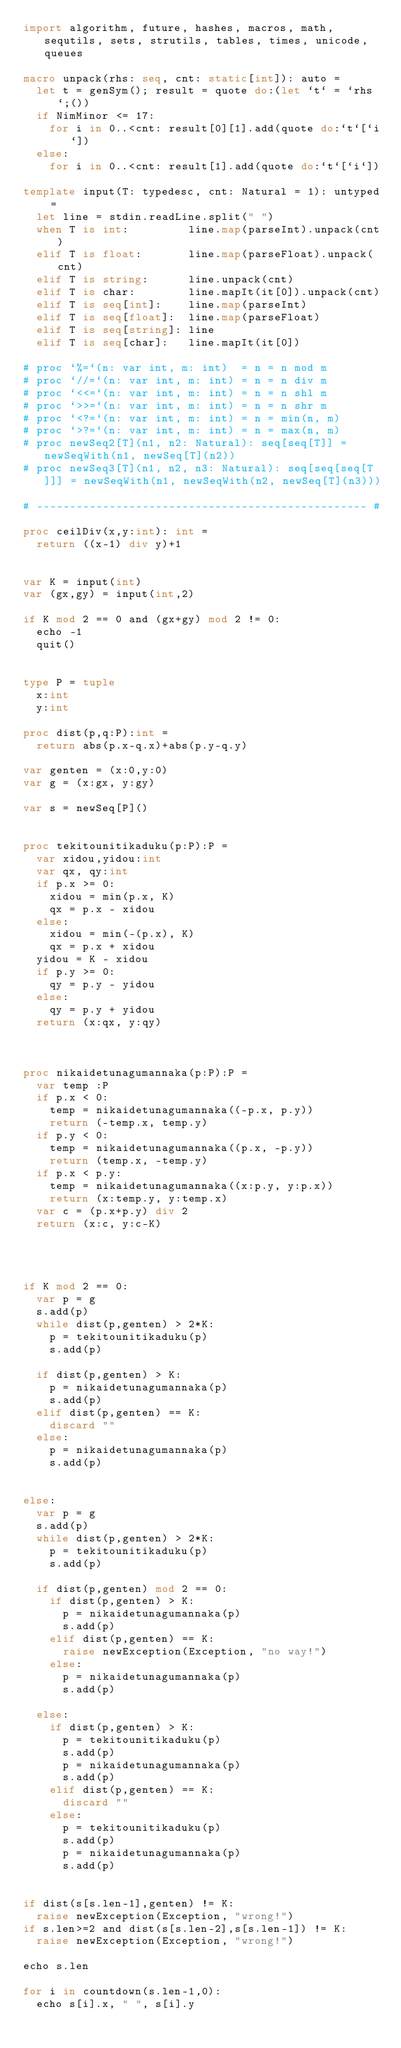Convert code to text. <code><loc_0><loc_0><loc_500><loc_500><_Nim_>import algorithm, future, hashes, macros, math, sequtils, sets, strutils, tables, times, unicode, queues
 
macro unpack(rhs: seq, cnt: static[int]): auto =
  let t = genSym(); result = quote do:(let `t` = `rhs`;())
  if NimMinor <= 17:
    for i in 0..<cnt: result[0][1].add(quote do:`t`[`i`])
  else:
    for i in 0..<cnt: result[1].add(quote do:`t`[`i`])
 
template input(T: typedesc, cnt: Natural = 1): untyped =
  let line = stdin.readLine.split(" ")
  when T is int:         line.map(parseInt).unpack(cnt)
  elif T is float:       line.map(parseFloat).unpack(cnt)
  elif T is string:      line.unpack(cnt)
  elif T is char:        line.mapIt(it[0]).unpack(cnt)
  elif T is seq[int]:    line.map(parseInt)
  elif T is seq[float]:  line.map(parseFloat)
  elif T is seq[string]: line
  elif T is seq[char]:   line.mapIt(it[0])
 
# proc `%=`(n: var int, m: int)  = n = n mod m
# proc `//=`(n: var int, m: int) = n = n div m
# proc `<<=`(n: var int, m: int) = n = n shl m
# proc `>>=`(n: var int, m: int) = n = n shr m
# proc `<?=`(n: var int, m: int) = n = min(n, m)
# proc `>?=`(n: var int, m: int) = n = max(n, m)
# proc newSeq2[T](n1, n2: Natural): seq[seq[T]] = newSeqWith(n1, newSeq[T](n2))
# proc newSeq3[T](n1, n2, n3: Natural): seq[seq[seq[T]]] = newSeqWith(n1, newSeqWith(n2, newSeq[T](n3)))
 
# -------------------------------------------------- #

proc ceilDiv(x,y:int): int =
  return ((x-1) div y)+1


var K = input(int)
var (gx,gy) = input(int,2)

if K mod 2 == 0 and (gx+gy) mod 2 != 0:
  echo -1
  quit()


type P = tuple
  x:int
  y:int

proc dist(p,q:P):int =
  return abs(p.x-q.x)+abs(p.y-q.y)

var genten = (x:0,y:0)
var g = (x:gx, y:gy)

var s = newSeq[P]()


proc tekitounitikaduku(p:P):P =
  var xidou,yidou:int
  var qx, qy:int
  if p.x >= 0:
    xidou = min(p.x, K)
    qx = p.x - xidou
  else:
    xidou = min(-(p.x), K)
    qx = p.x + xidou
  yidou = K - xidou
  if p.y >= 0:
    qy = p.y - yidou
  else:
    qy = p.y + yidou
  return (x:qx, y:qy)



proc nikaidetunagumannaka(p:P):P =
  var temp :P
  if p.x < 0:
    temp = nikaidetunagumannaka((-p.x, p.y))
    return (-temp.x, temp.y)
  if p.y < 0:
    temp = nikaidetunagumannaka((p.x, -p.y))
    return (temp.x, -temp.y)
  if p.x < p.y:
    temp = nikaidetunagumannaka((x:p.y, y:p.x))
    return (x:temp.y, y:temp.x)
  var c = (p.x+p.y) div 2
  return (x:c, y:c-K)




if K mod 2 == 0:
  var p = g
  s.add(p)
  while dist(p,genten) > 2*K:
    p = tekitounitikaduku(p)
    s.add(p)

  if dist(p,genten) > K:
    p = nikaidetunagumannaka(p)
    s.add(p)
  elif dist(p,genten) == K:
    discard ""
  else:
    p = nikaidetunagumannaka(p)
    s.add(p)


else:
  var p = g
  s.add(p)
  while dist(p,genten) > 2*K:
    p = tekitounitikaduku(p)
    s.add(p)

  if dist(p,genten) mod 2 == 0:
    if dist(p,genten) > K:
      p = nikaidetunagumannaka(p)
      s.add(p)
    elif dist(p,genten) == K:
      raise newException(Exception, "no way!")
    else:
      p = nikaidetunagumannaka(p)
      s.add(p)

  else:
    if dist(p,genten) > K:
      p = tekitounitikaduku(p)
      s.add(p)
      p = nikaidetunagumannaka(p)
      s.add(p)
    elif dist(p,genten) == K:
      discard ""
    else:
      p = tekitounitikaduku(p)
      s.add(p)
      p = nikaidetunagumannaka(p)
      s.add(p)


if dist(s[s.len-1],genten) != K:
  raise newException(Exception, "wrong!")
if s.len>=2 and dist(s[s.len-2],s[s.len-1]) != K:
  raise newException(Exception, "wrong!")

echo s.len

for i in countdown(s.len-1,0):
  echo s[i].x, " ", s[i].y


</code> 